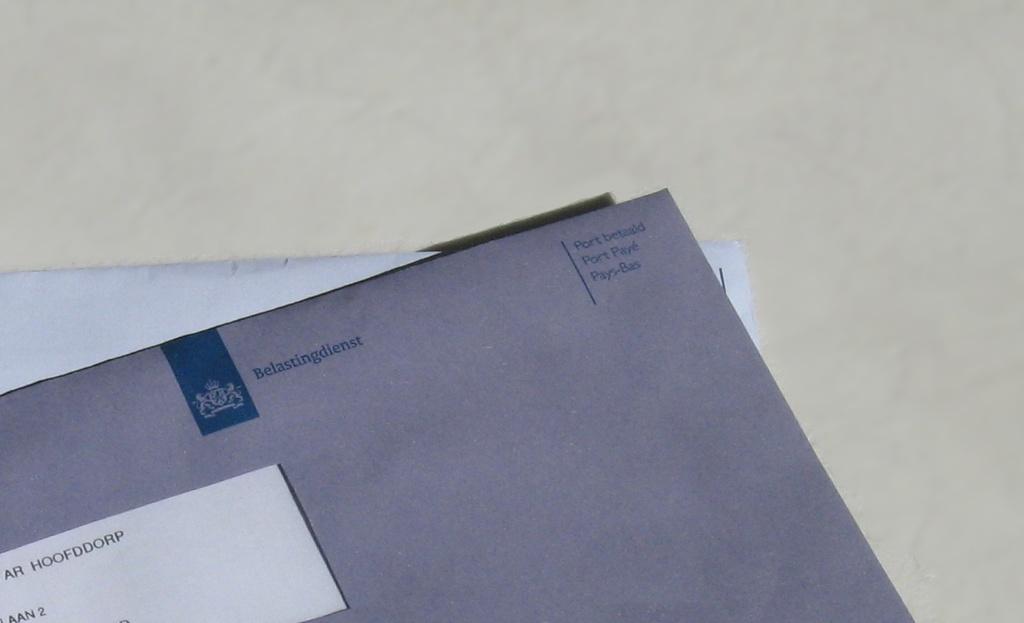What does it say next to the logo?
Your answer should be compact. Belastingdienst. 